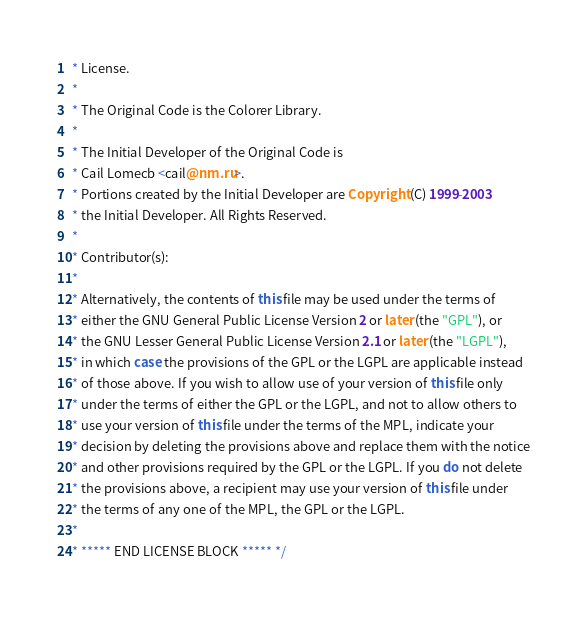Convert code to text. <code><loc_0><loc_0><loc_500><loc_500><_Java_> * License.
 *
 * The Original Code is the Colorer Library.
 *
 * The Initial Developer of the Original Code is
 * Cail Lomecb <cail@nm.ru>.
 * Portions created by the Initial Developer are Copyright (C) 1999-2003
 * the Initial Developer. All Rights Reserved.
 *
 * Contributor(s):
 *
 * Alternatively, the contents of this file may be used under the terms of
 * either the GNU General Public License Version 2 or later (the "GPL"), or
 * the GNU Lesser General Public License Version 2.1 or later (the "LGPL"),
 * in which case the provisions of the GPL or the LGPL are applicable instead
 * of those above. If you wish to allow use of your version of this file only
 * under the terms of either the GPL or the LGPL, and not to allow others to
 * use your version of this file under the terms of the MPL, indicate your
 * decision by deleting the provisions above and replace them with the notice
 * and other provisions required by the GPL or the LGPL. If you do not delete
 * the provisions above, a recipient may use your version of this file under
 * the terms of any one of the MPL, the GPL or the LGPL.
 *
 * ***** END LICENSE BLOCK ***** */</code> 